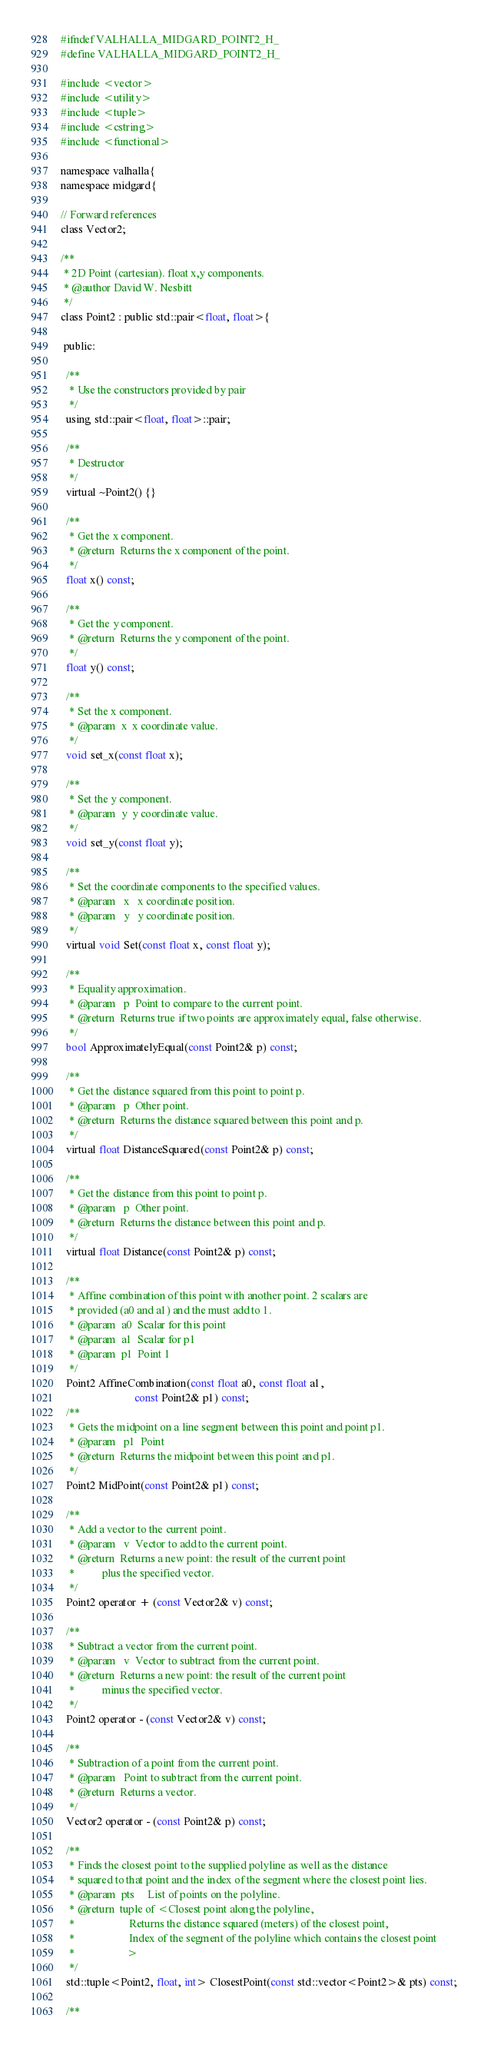<code> <loc_0><loc_0><loc_500><loc_500><_C_>#ifndef VALHALLA_MIDGARD_POINT2_H_
#define VALHALLA_MIDGARD_POINT2_H_

#include <vector>
#include <utility>
#include <tuple>
#include <cstring>
#include <functional>

namespace valhalla{
namespace midgard{

// Forward references
class Vector2;

/**
 * 2D Point (cartesian). float x,y components.
 * @author David W. Nesbitt
 */
class Point2 : public std::pair<float, float>{

 public:

  /**
   * Use the constructors provided by pair
   */
  using std::pair<float, float>::pair;

  /**
   * Destructor
   */
  virtual ~Point2() {}

  /**
   * Get the x component.
   * @return  Returns the x component of the point.
   */
  float x() const;

  /**
   * Get the y component.
   * @return  Returns the y component of the point.
   */
  float y() const;

  /**
   * Set the x component.
   * @param  x  x coordinate value.
   */
  void set_x(const float x);

  /**
   * Set the y component.
   * @param  y  y coordinate value.
   */
  void set_y(const float y);

  /**
   * Set the coordinate components to the specified values.
   * @param   x   x coordinate position.
   * @param   y   y coordinate position.
   */
  virtual void Set(const float x, const float y);

  /**
   * Equality approximation.
   * @param   p  Point to compare to the current point.
   * @return  Returns true if two points are approximately equal, false otherwise.
   */
  bool ApproximatelyEqual(const Point2& p) const;

  /**
   * Get the distance squared from this point to point p.
   * @param   p  Other point.
   * @return  Returns the distance squared between this point and p.
   */
  virtual float DistanceSquared(const Point2& p) const;

  /**
   * Get the distance from this point to point p.
   * @param   p  Other point.
   * @return  Returns the distance between this point and p.
   */
  virtual float Distance(const Point2& p) const;

  /**
   * Affine combination of this point with another point. 2 scalars are
   * provided (a0 and a1) and the must add to 1.
   * @param  a0  Scalar for this point
   * @param  a1  Scalar for p1
   * @param  p1  Point 1
   */
  Point2 AffineCombination(const float a0, const float a1,
                           const Point2& p1) const;
  /**
   * Gets the midpoint on a line segment between this point and point p1.
   * @param   p1  Point
   * @return  Returns the midpoint between this point and p1.
   */
  Point2 MidPoint(const Point2& p1) const;

  /**
   * Add a vector to the current point.
   * @param   v  Vector to add to the current point.
   * @return  Returns a new point: the result of the current point
   *          plus the specified vector.
   */
  Point2 operator + (const Vector2& v) const;

  /**
   * Subtract a vector from the current point.
   * @param   v  Vector to subtract from the current point.
   * @return  Returns a new point: the result of the current point
   *          minus the specified vector.
   */
  Point2 operator - (const Vector2& v) const;

  /**
   * Subtraction of a point from the current point.
   * @param   Point to subtract from the current point.
   * @return  Returns a vector.
   */
  Vector2 operator - (const Point2& p) const;

  /**
   * Finds the closest point to the supplied polyline as well as the distance
   * squared to that point and the index of the segment where the closest point lies.
   * @param  pts     List of points on the polyline.
   * @return  tuple of <Closest point along the polyline,
   *                    Returns the distance squared (meters) of the closest point,
   *                    Index of the segment of the polyline which contains the closest point
   *                   >
   */
  std::tuple<Point2, float, int> ClosestPoint(const std::vector<Point2>& pts) const;

  /**</code> 